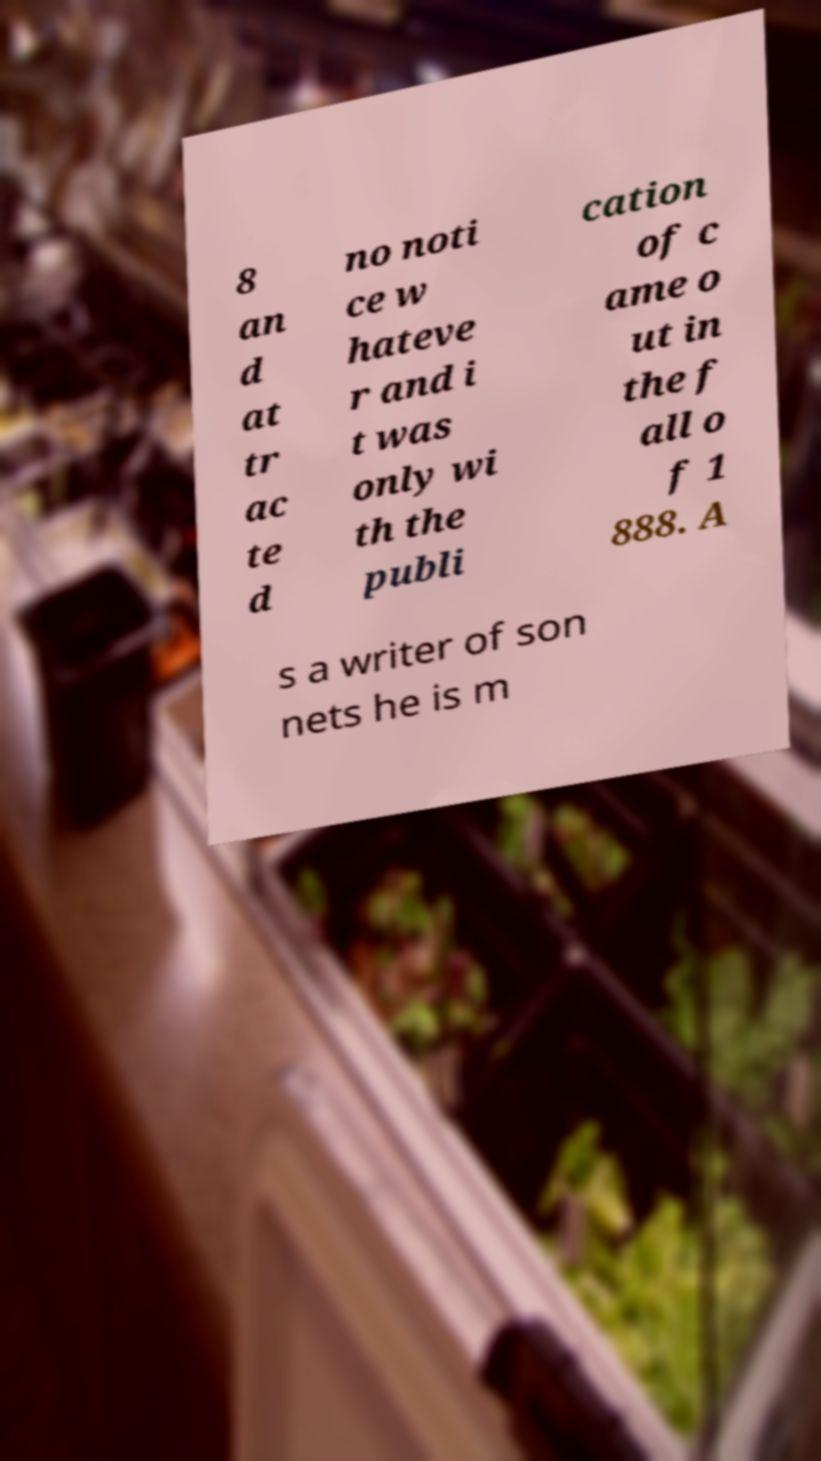For documentation purposes, I need the text within this image transcribed. Could you provide that? 8 an d at tr ac te d no noti ce w hateve r and i t was only wi th the publi cation of c ame o ut in the f all o f 1 888. A s a writer of son nets he is m 